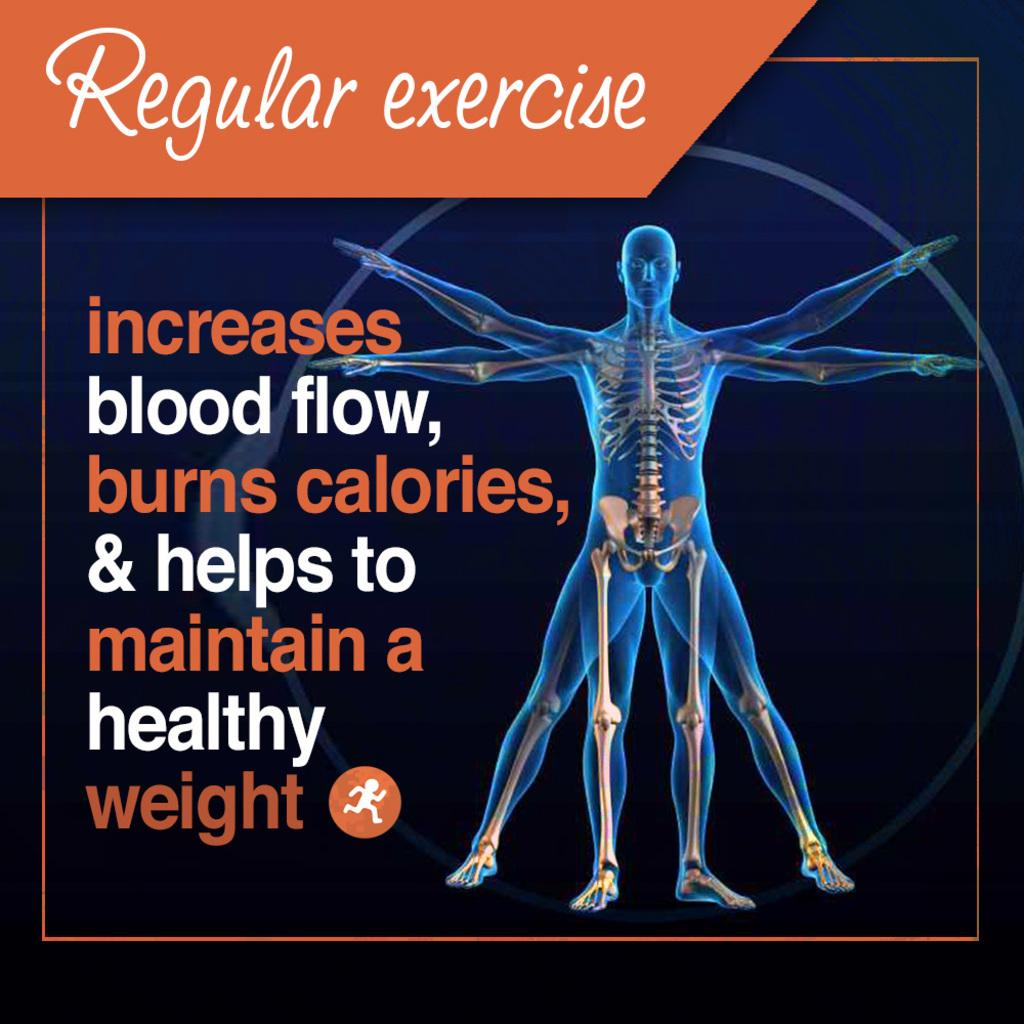<image>
Share a concise interpretation of the image provided. Front cover of something that says, Regular exercise increases blood flow, burns calories, & helps to maintain a healthy weight. 